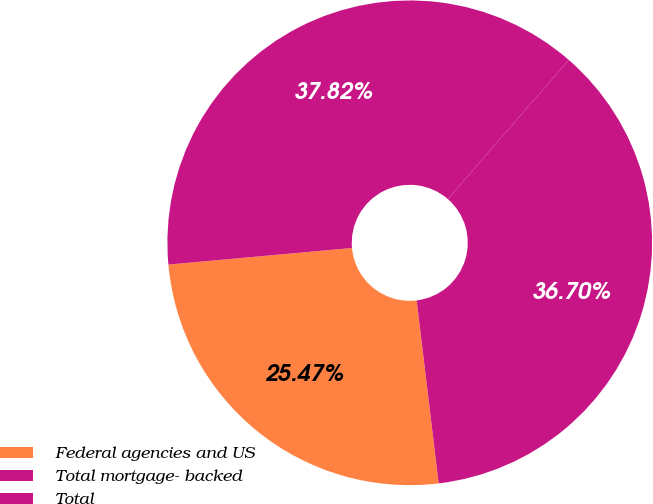Convert chart to OTSL. <chart><loc_0><loc_0><loc_500><loc_500><pie_chart><fcel>Federal agencies and US<fcel>Total mortgage- backed<fcel>Total<nl><fcel>25.47%<fcel>36.7%<fcel>37.82%<nl></chart> 